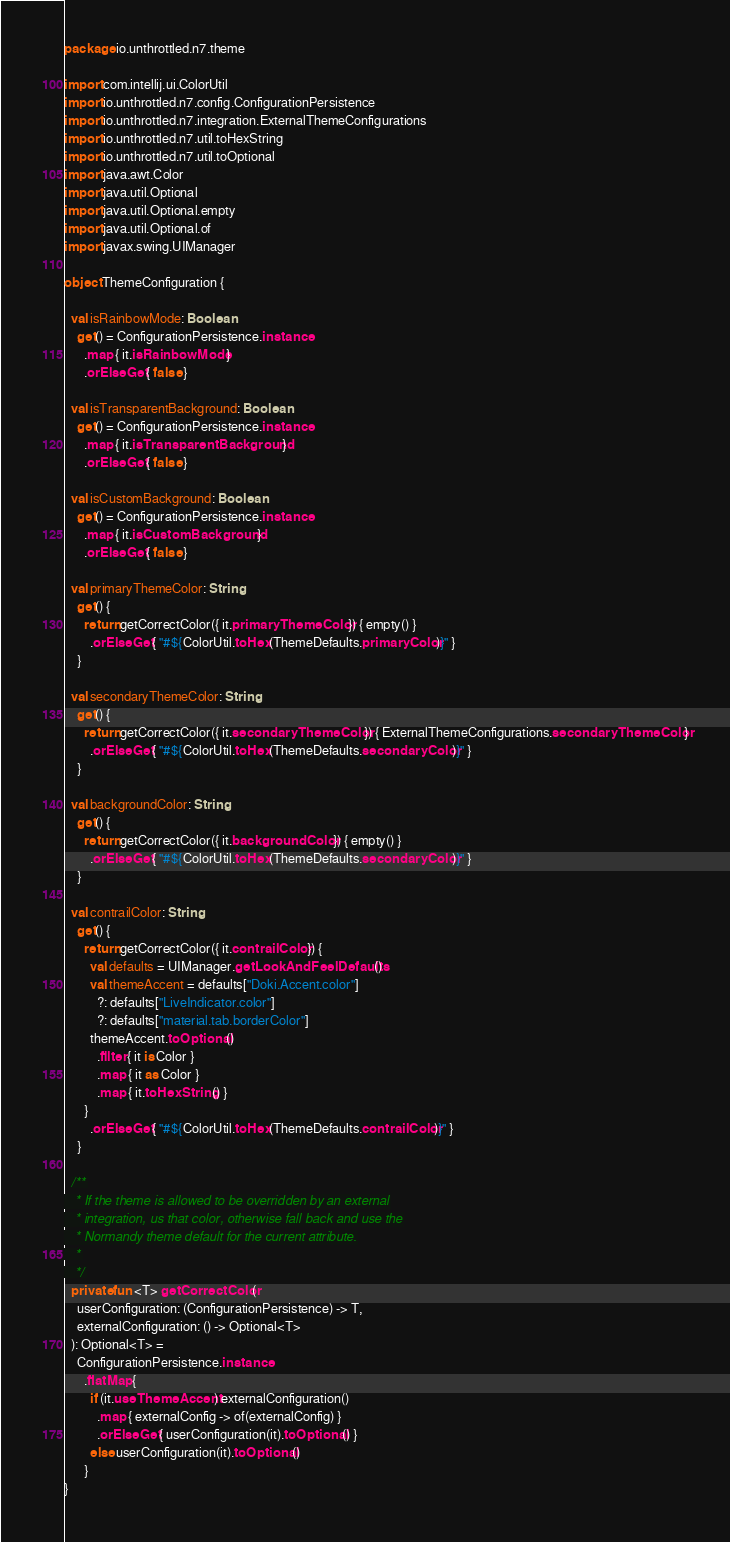<code> <loc_0><loc_0><loc_500><loc_500><_Kotlin_>package io.unthrottled.n7.theme

import com.intellij.ui.ColorUtil
import io.unthrottled.n7.config.ConfigurationPersistence
import io.unthrottled.n7.integration.ExternalThemeConfigurations
import io.unthrottled.n7.util.toHexString
import io.unthrottled.n7.util.toOptional
import java.awt.Color
import java.util.Optional
import java.util.Optional.empty
import java.util.Optional.of
import javax.swing.UIManager

object ThemeConfiguration {

  val isRainbowMode: Boolean
    get() = ConfigurationPersistence.instance
      .map { it.isRainbowMode }
      .orElseGet { false }

  val isTransparentBackground: Boolean
    get() = ConfigurationPersistence.instance
      .map { it.isTransparentBackground }
      .orElseGet { false }

  val isCustomBackground: Boolean
    get() = ConfigurationPersistence.instance
      .map { it.isCustomBackground }
      .orElseGet { false }

  val primaryThemeColor: String
    get() {
      return getCorrectColor({ it.primaryThemeColor }) { empty() }
        .orElseGet { "#${ColorUtil.toHex(ThemeDefaults.primaryColor)}" }
    }

  val secondaryThemeColor: String
    get() {
      return getCorrectColor({ it.secondaryThemeColor }) { ExternalThemeConfigurations.secondaryThemeColor }
        .orElseGet { "#${ColorUtil.toHex(ThemeDefaults.secondaryColor)}" }
    }

  val backgroundColor: String
    get() {
      return getCorrectColor({ it.backgroundColor }) { empty() }
        .orElseGet { "#${ColorUtil.toHex(ThemeDefaults.secondaryColor)}" }
    }

  val contrailColor: String
    get() {
      return getCorrectColor({ it.contrailColor }) {
        val defaults = UIManager.getLookAndFeelDefaults()
        val themeAccent = defaults["Doki.Accent.color"]
          ?: defaults["LiveIndicator.color"]
          ?: defaults["material.tab.borderColor"]
        themeAccent.toOptional()
          .filter { it is Color }
          .map { it as Color }
          .map { it.toHexString() }
      }
        .orElseGet { "#${ColorUtil.toHex(ThemeDefaults.contrailColor)}" }
    }

  /**
   * If the theme is allowed to be overridden by an external
   * integration, us that color, otherwise fall back and use the
   * Normandy theme default for the current attribute.
   *
   */
  private fun <T> getCorrectColor(
    userConfiguration: (ConfigurationPersistence) -> T,
    externalConfiguration: () -> Optional<T>
  ): Optional<T> =
    ConfigurationPersistence.instance
      .flatMap {
        if (it.useThemeAccent) externalConfiguration()
          .map { externalConfig -> of(externalConfig) }
          .orElseGet { userConfiguration(it).toOptional() }
        else userConfiguration(it).toOptional()
      }
}
</code> 